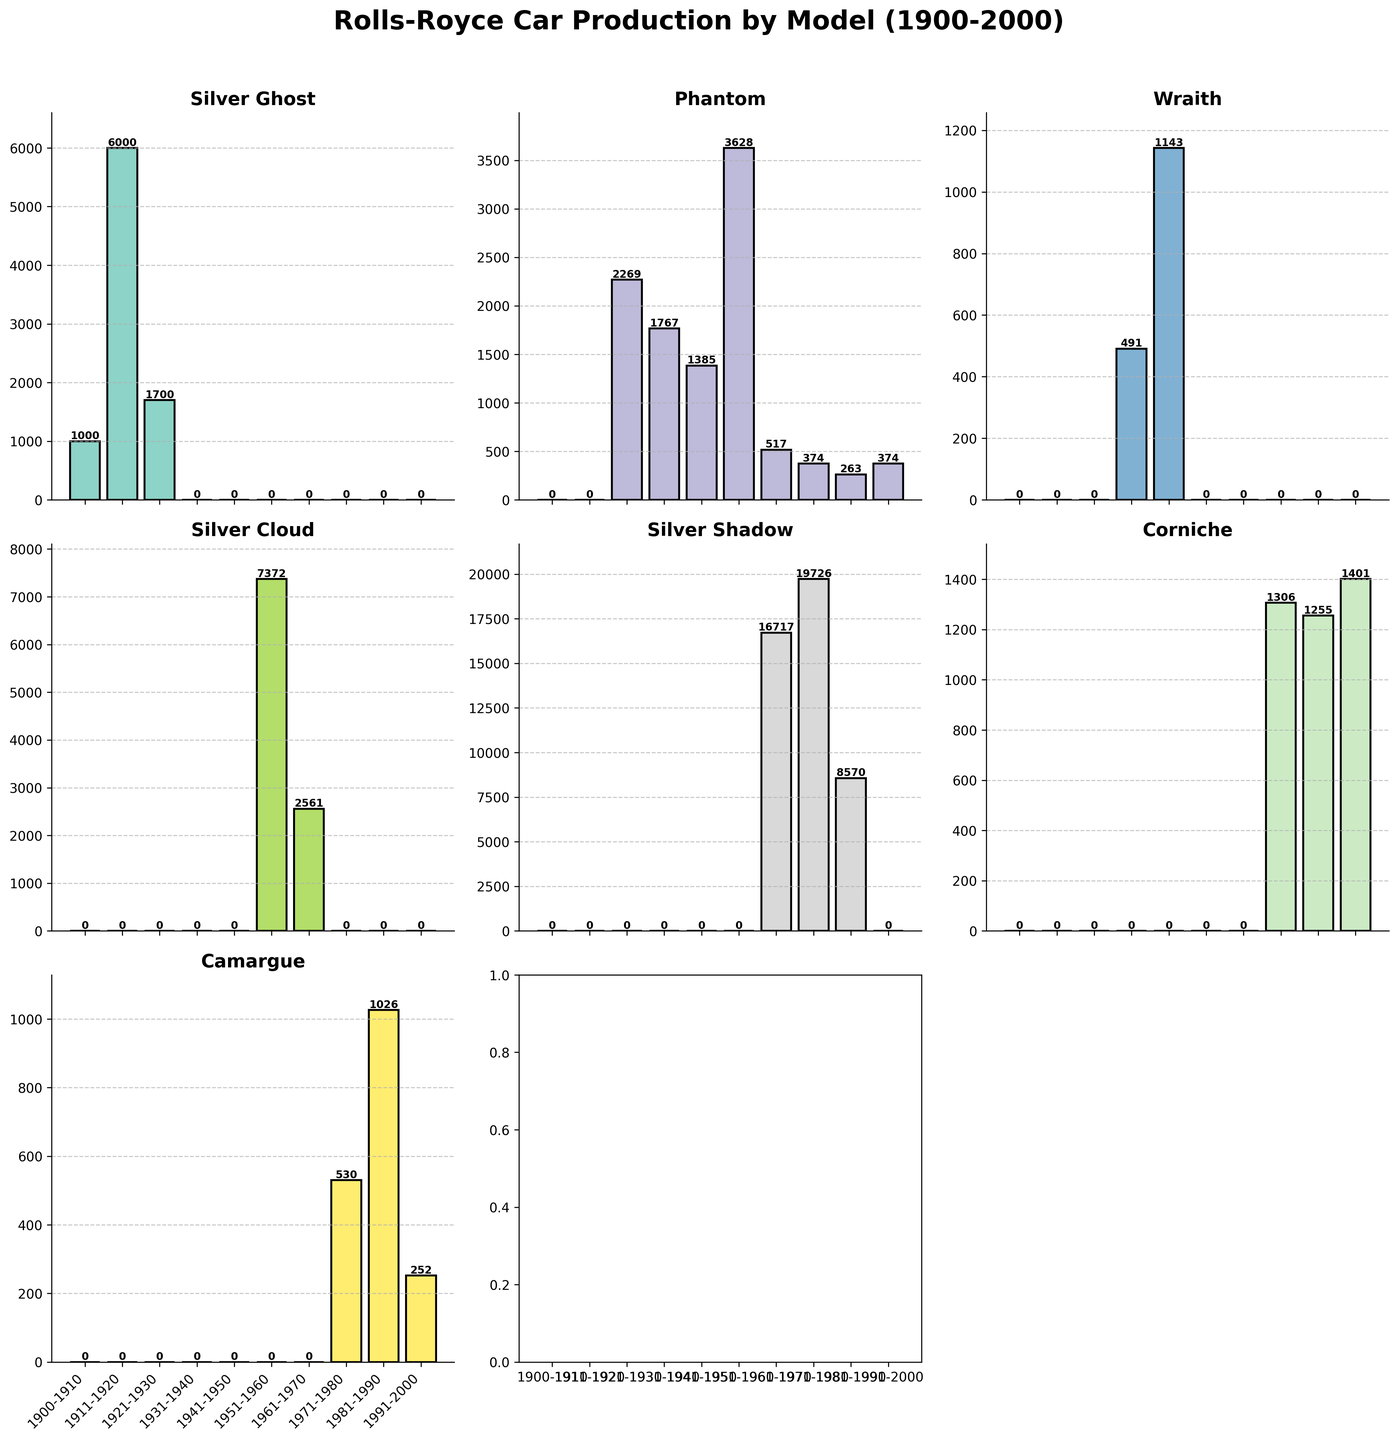What is the title of the figure? The title is displayed at the top of the figure in bold and larger font.
Answer: Rolls-Royce Car Production by Model (1900-2000) Which model had the highest production in the decade 1971-1980? Look at the bars in the subplot for each model in the 1971-1980 decade and find the highest bar.
Answer: Silver Shadow What is the average production of the Phantom model across all decades? Sum the production numbers for the Phantom model across all decades and divide by the number of decades.
Answer: (0 + 0 + 2269 + 1767 + 1385 + 3628 + 517 + 374 + 263 + 374) / 10 = 957.7 How many models were produced in the 1991-2000 decade? Identify the number of subplots that have bars greater than zero in the 1991-2000 decade.
Answer: 3 Which decade showed the highest overall production for all models combined? Sum the production numbers for all models in each decade and find the decade with the highest total.
Answer: 1961-1970 What is the range of production for the Silver Ghost model across all decades? Find the difference between the maximum and minimum production numbers for the Silver Ghost model.
Answer: 6000 - 0 = 6000 Compare the production of the Silver Cloud model in the 1951-1960 and 1961-1970 decades and determine which decade had more production. Look at the height of the bars for the Silver Cloud in the specified decades and compare them.
Answer: 1951-1960 What is the median production number for the Corniche model across all decades? Arrange the production numbers for the Corniche model in ascending order and find the median value.
Answer: 1306 How many models had zero production in the decade 1900-1910? Count the number of subplots with bars of height zero in the 1900-1910 decade.
Answer: 6 